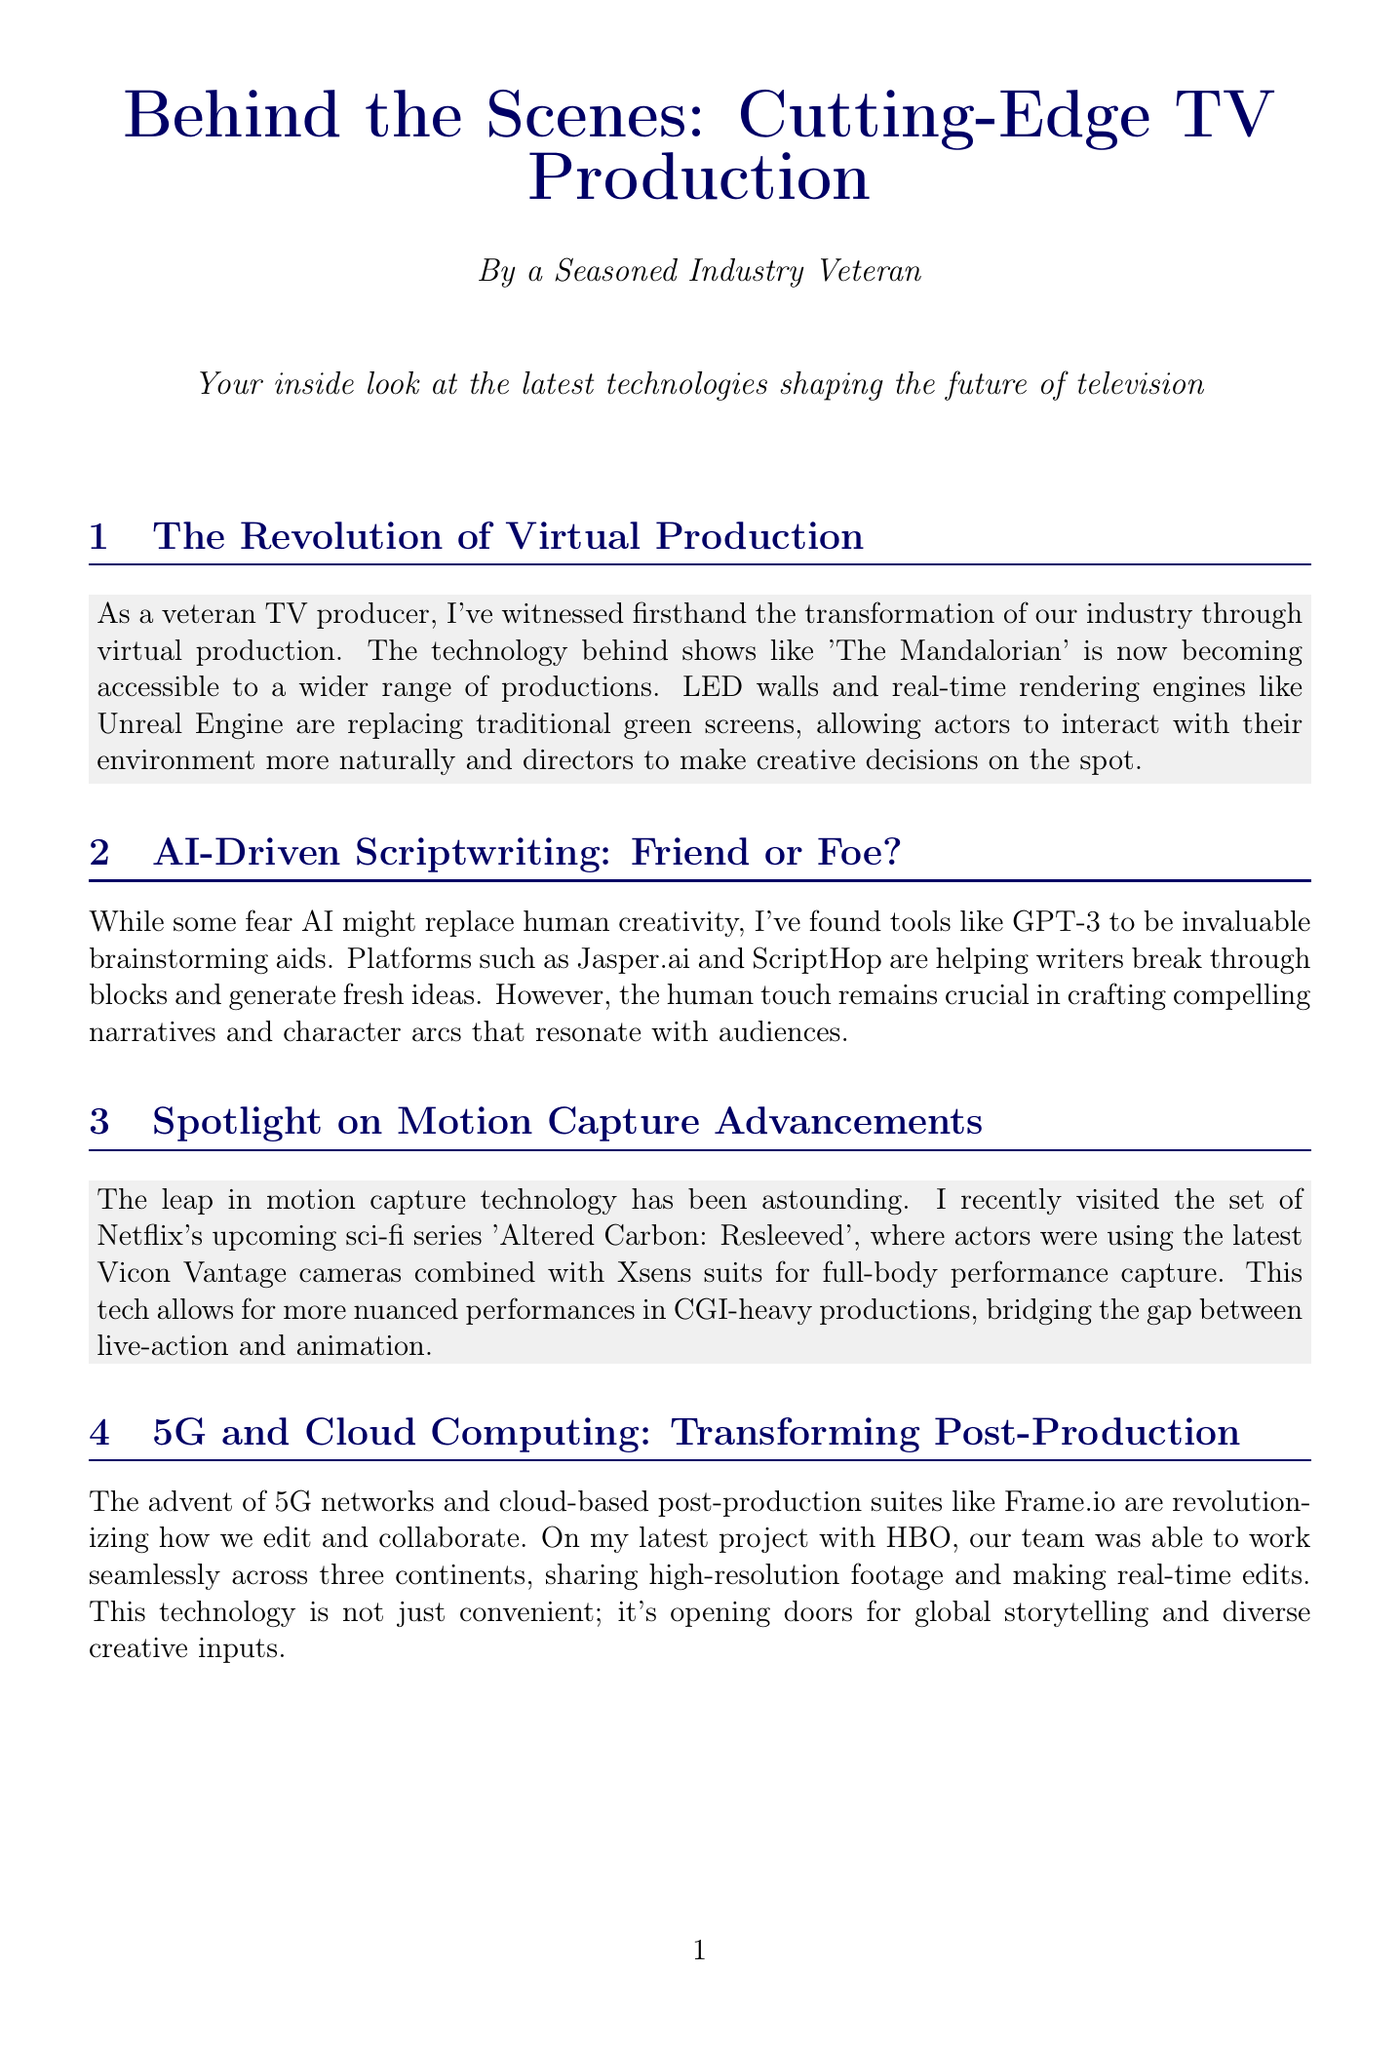What technology is replacing traditional green screens? The document states that LED walls and real-time rendering engines like Unreal Engine are replacing traditional green screens in productions.
Answer: LED walls and Unreal Engine What project was mentioned in connection with AI-driven scriptwriting tools? The newsletter references platforms such as Jasper.ai and ScriptHop as valuable aids for writers in brainstorming.
Answer: Jasper.ai and ScriptHop Which Netflix series featured advancements in motion capture technology? The newsletter highlights that the set of Netflix's upcoming sci-fi series 'Altered Carbon: Resleeved' showcased these advancements.
Answer: Altered Carbon: Resleeved What technology is used for virtual location scouting? The document mentions Nvidia Omniverse as the tool enabling virtual location scouting to reduce travel needs.
Answer: Nvidia Omniverse What is the focus of the section titled "Interactive Storytelling: The Next Frontier"? This section discusses the blurring lines between TV and gaming, citing Netflix's 'Black Mirror: Bandersnatch' as a successful example of interactive narratives.
Answer: Blurring lines between TV and gaming How did 5G and cloud computing impact post-production according to the newsletter? The document explains that these technologies enabled seamless collaboration and editing across three continents for a project.
Answer: Seamless collaboration and editing across continents What innovative approach did the author use for the series 'The Expanse: Beyond'? The newsletter indicates that virtual location scouting was utilized to design and experience alien worlds prior to building sets.
Answer: Virtual location scouting How does the author view the role of AI in scriptwriting? The author finds AI tools like GPT-3 to be valuable brainstorming aids while emphasizing that human creativity is still essential.
Answer: Valuable brainstorming aids What does the technology presented in 'Black Mirror: Bandersnatch' represent? The section on interactive storytelling mentions that it represents a shift toward interactive narratives in television.
Answer: Shift toward interactive narratives 